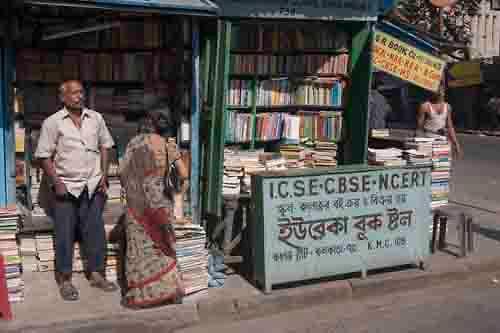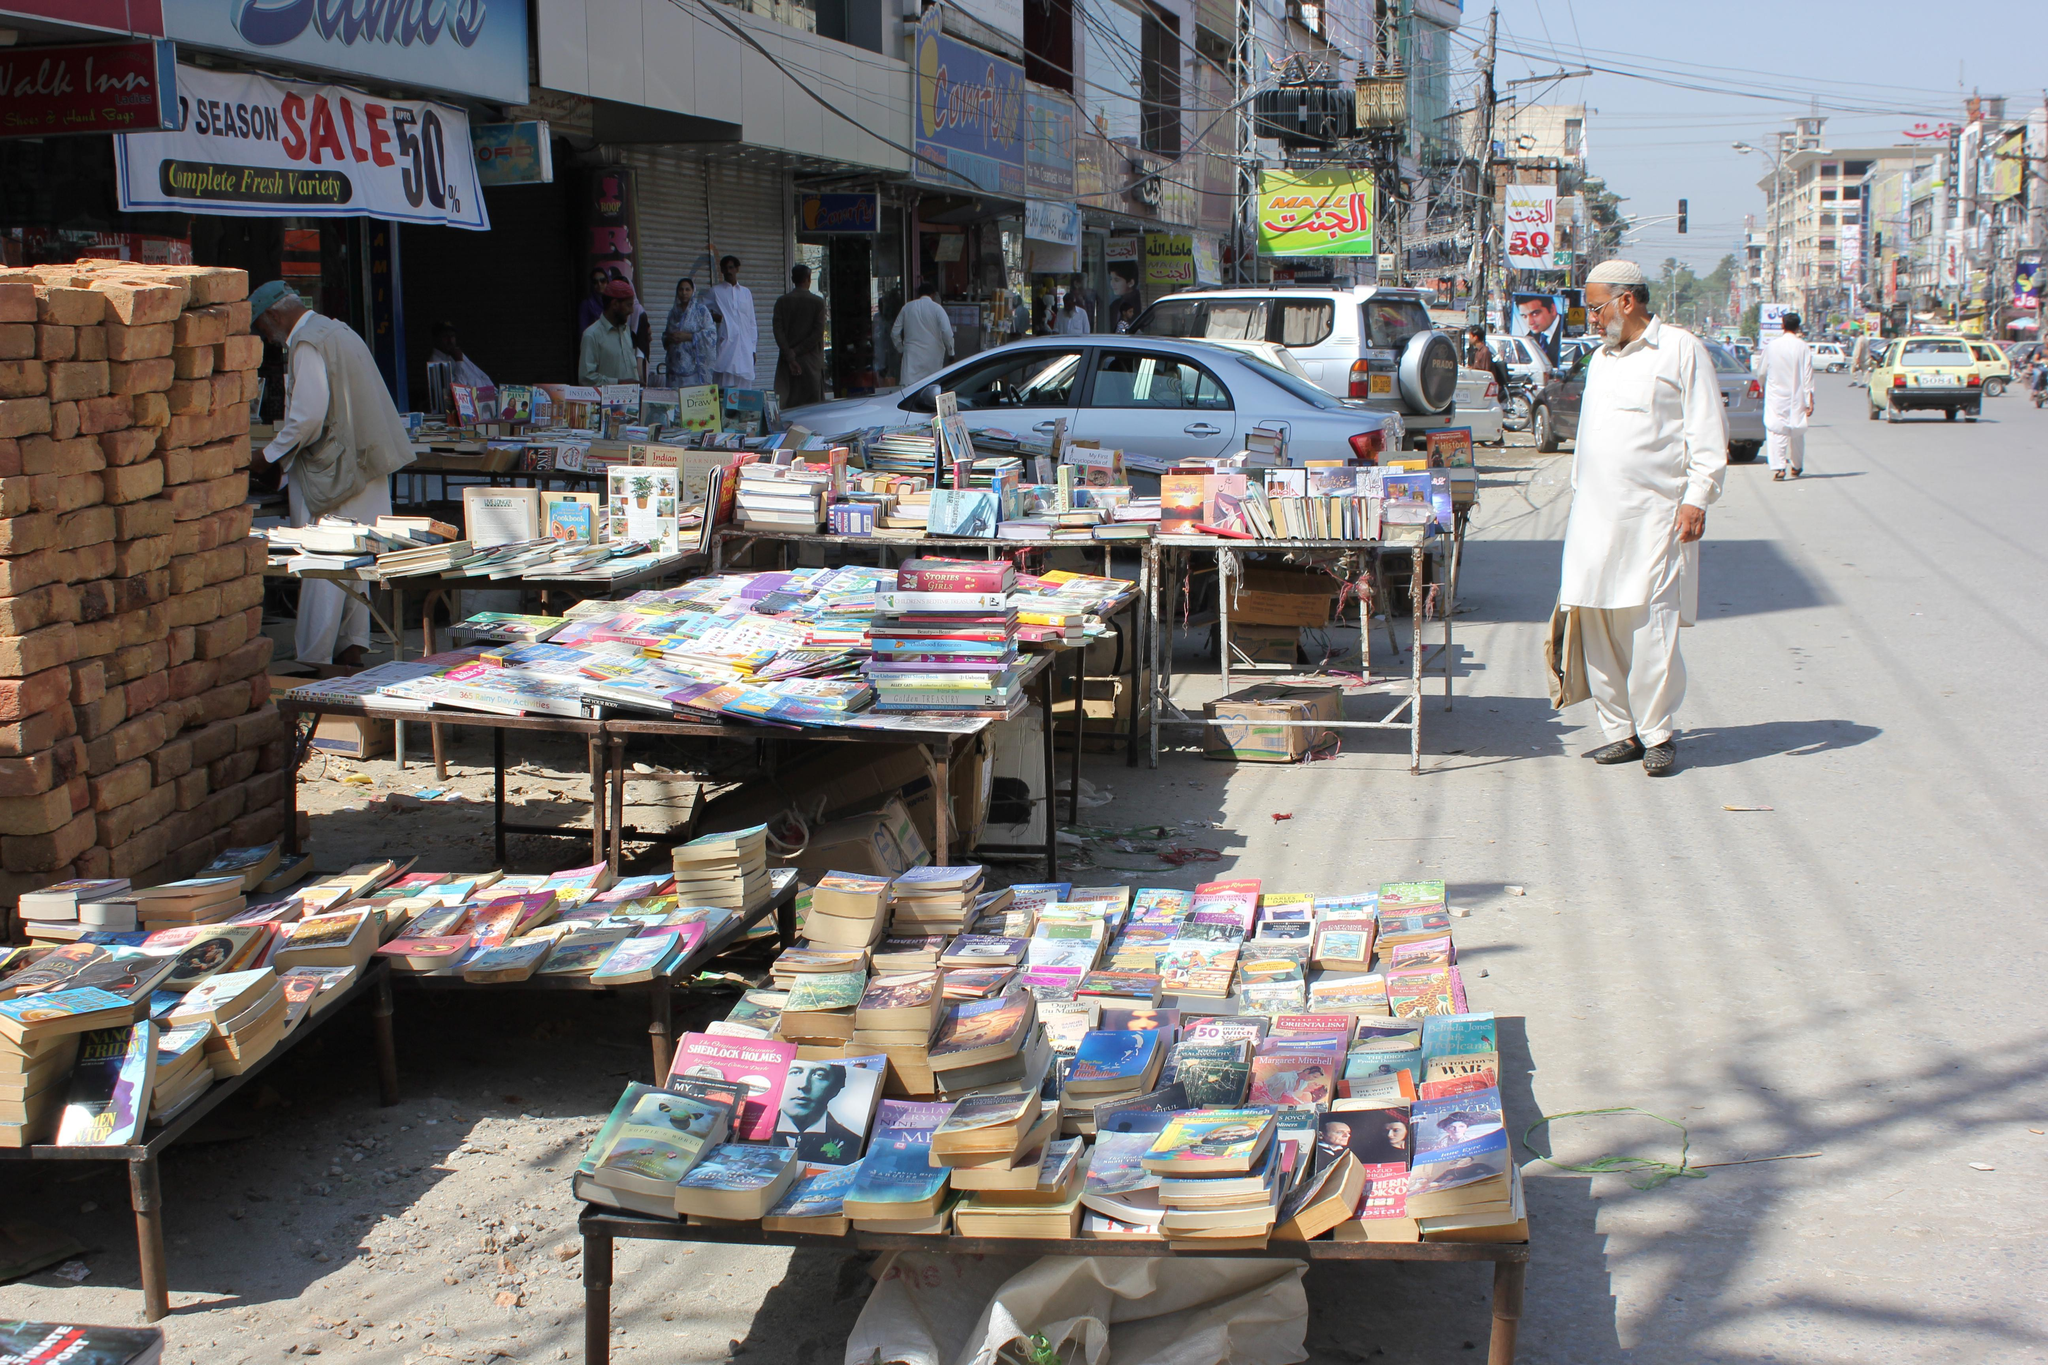The first image is the image on the left, the second image is the image on the right. Examine the images to the left and right. Is the description "A vehicle is parked in the area near the sales in the image on the right." accurate? Answer yes or no. Yes. The first image is the image on the left, the second image is the image on the right. Analyze the images presented: Is the assertion "The sky is partially visible behind a book stall in the right image." valid? Answer yes or no. Yes. 